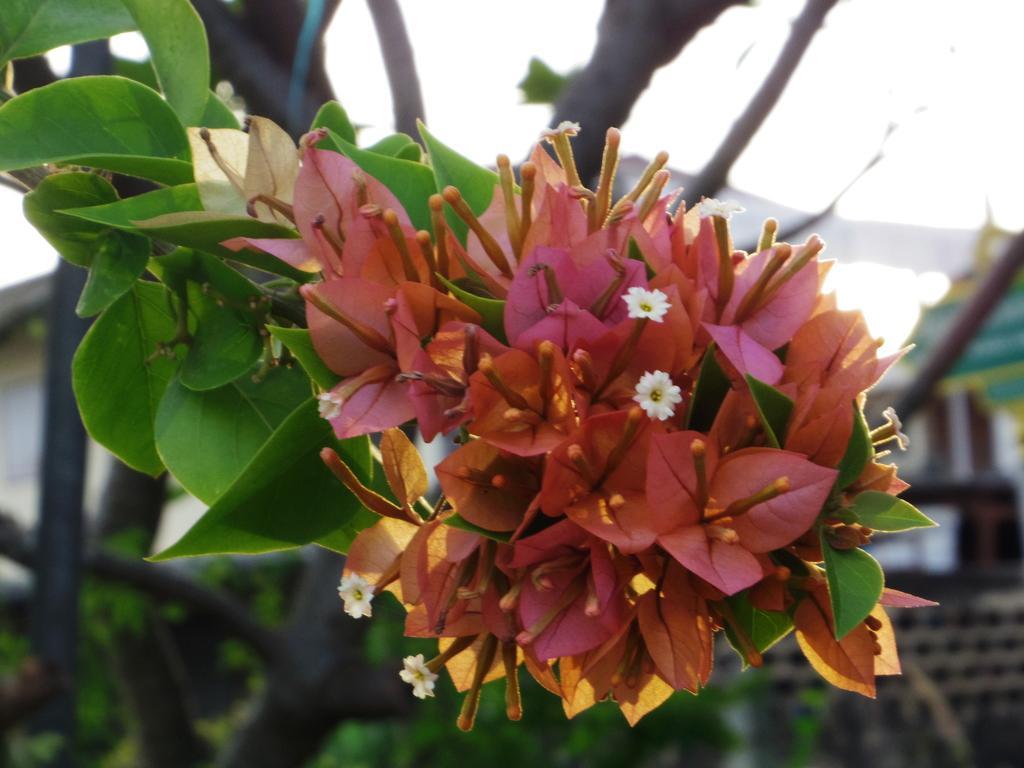Can you describe this image briefly? In this image we can see there are so many flowers on the tree behind that there is a building. 